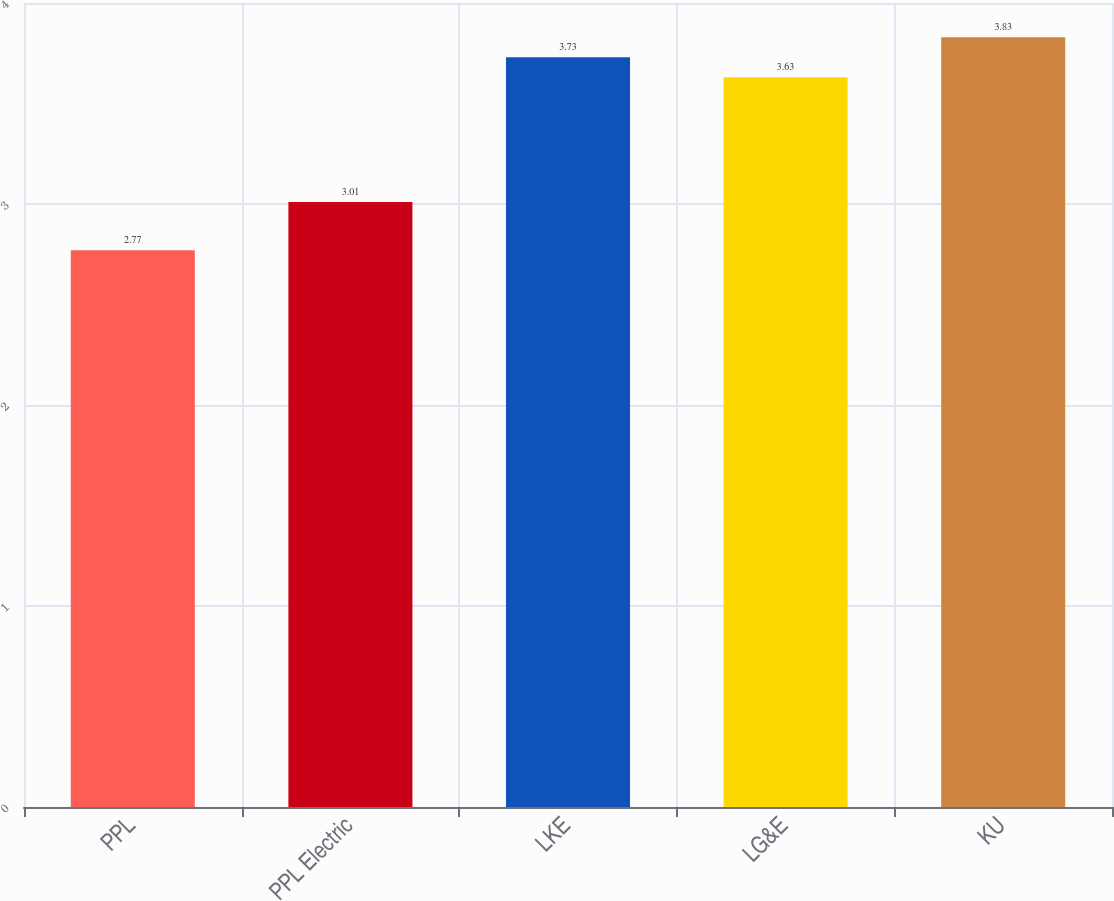Convert chart. <chart><loc_0><loc_0><loc_500><loc_500><bar_chart><fcel>PPL<fcel>PPL Electric<fcel>LKE<fcel>LG&E<fcel>KU<nl><fcel>2.77<fcel>3.01<fcel>3.73<fcel>3.63<fcel>3.83<nl></chart> 